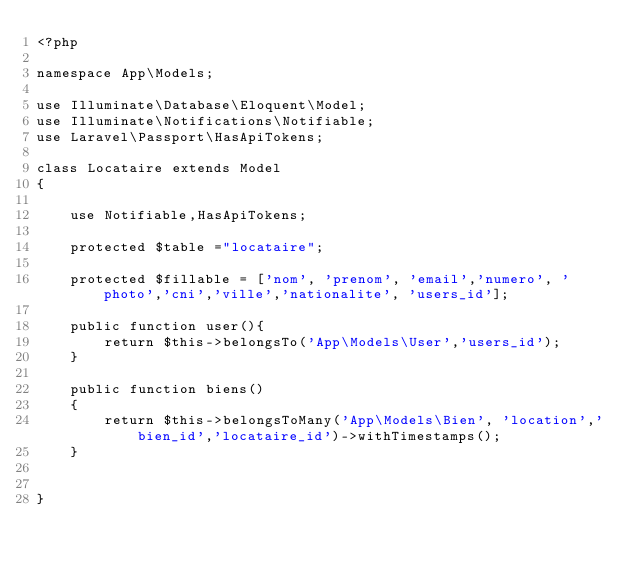Convert code to text. <code><loc_0><loc_0><loc_500><loc_500><_PHP_><?php

namespace App\Models;

use Illuminate\Database\Eloquent\Model;
use Illuminate\Notifications\Notifiable;
use Laravel\Passport\HasApiTokens;

class Locataire extends Model
{

    use Notifiable,HasApiTokens;

    protected $table ="locataire";

    protected $fillable = ['nom', 'prenom', 'email','numero', 'photo','cni','ville','nationalite', 'users_id'];

    public function user(){
        return $this->belongsTo('App\Models\User','users_id');
    }

    public function biens()
    {
        return $this->belongsToMany('App\Models\Bien', 'location','bien_id','locataire_id')->withTimestamps();
    }


}
</code> 